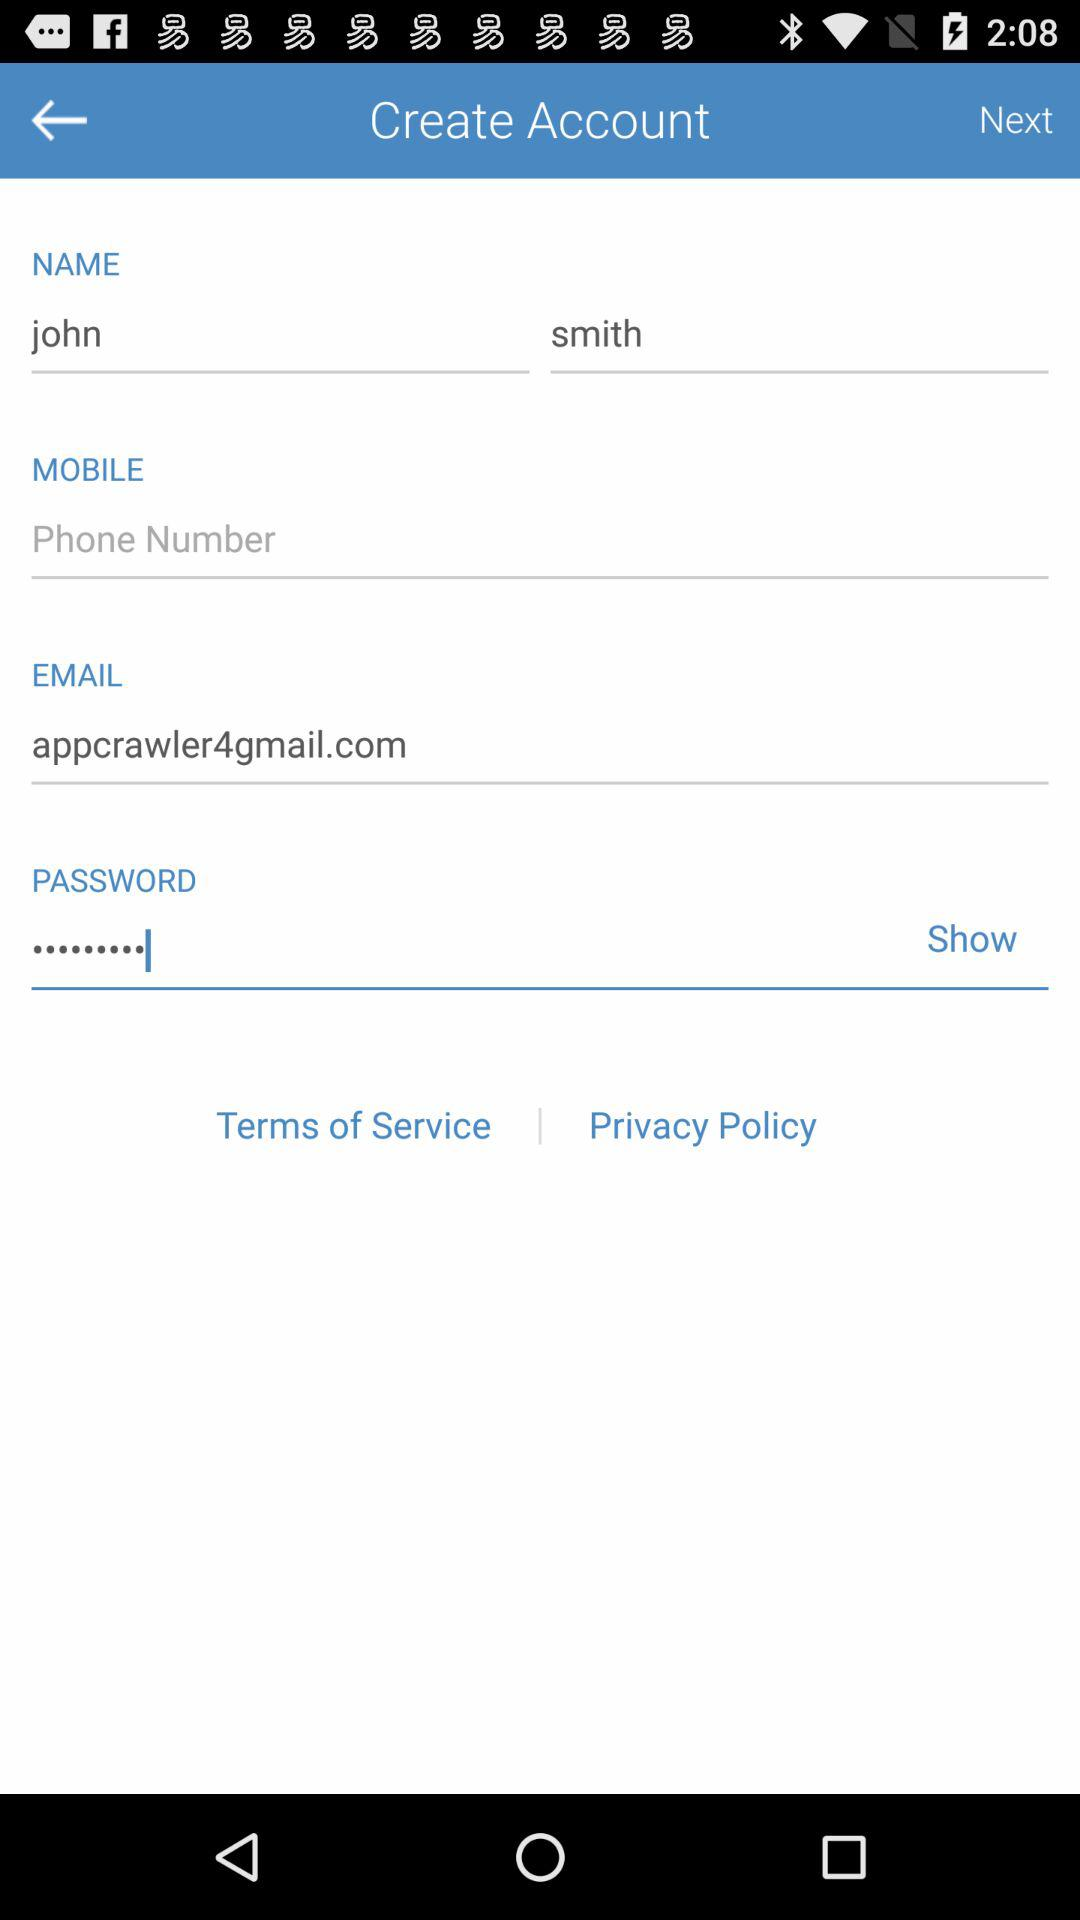What is the name of the user? The user name is John Smith. 